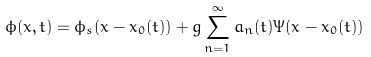Convert formula to latex. <formula><loc_0><loc_0><loc_500><loc_500>\phi ( x , t ) = \phi _ { s } ( x - x _ { 0 } ( t ) ) + g \sum _ { n = 1 } ^ { \infty } a _ { n } ( t ) \Psi ( x - x _ { 0 } ( t ) )</formula> 